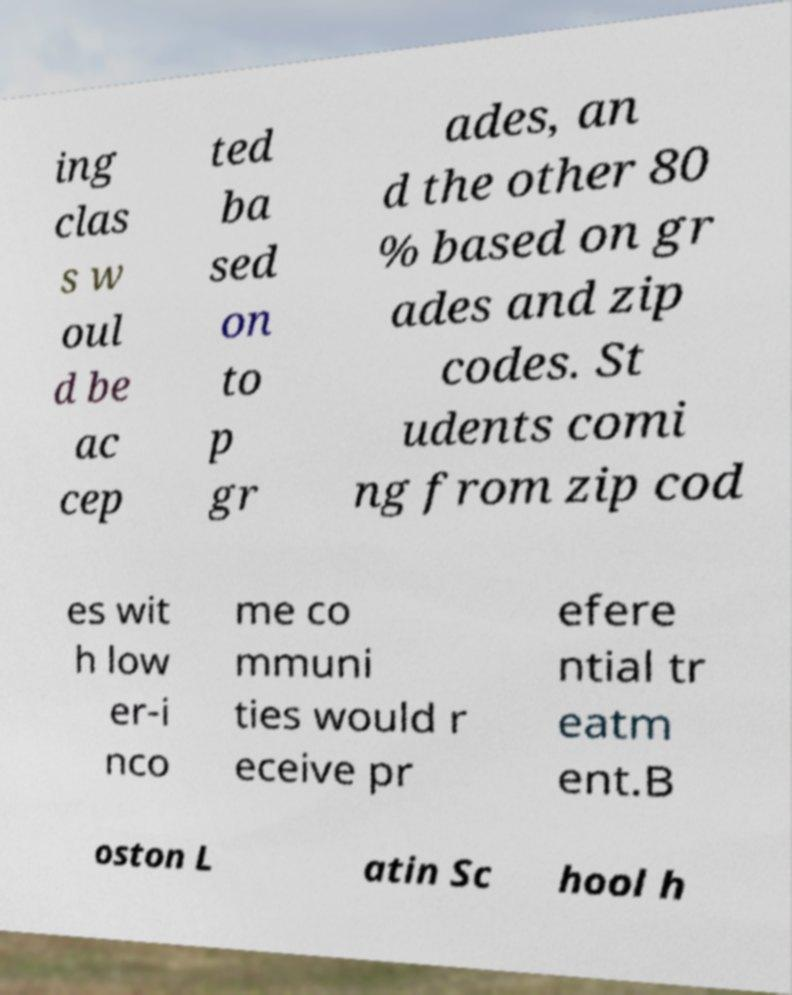Please read and relay the text visible in this image. What does it say? ing clas s w oul d be ac cep ted ba sed on to p gr ades, an d the other 80 % based on gr ades and zip codes. St udents comi ng from zip cod es wit h low er-i nco me co mmuni ties would r eceive pr efere ntial tr eatm ent.B oston L atin Sc hool h 